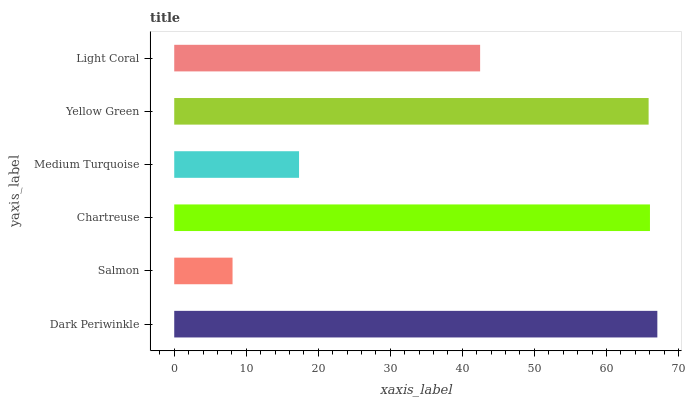Is Salmon the minimum?
Answer yes or no. Yes. Is Dark Periwinkle the maximum?
Answer yes or no. Yes. Is Chartreuse the minimum?
Answer yes or no. No. Is Chartreuse the maximum?
Answer yes or no. No. Is Chartreuse greater than Salmon?
Answer yes or no. Yes. Is Salmon less than Chartreuse?
Answer yes or no. Yes. Is Salmon greater than Chartreuse?
Answer yes or no. No. Is Chartreuse less than Salmon?
Answer yes or no. No. Is Yellow Green the high median?
Answer yes or no. Yes. Is Light Coral the low median?
Answer yes or no. Yes. Is Dark Periwinkle the high median?
Answer yes or no. No. Is Dark Periwinkle the low median?
Answer yes or no. No. 